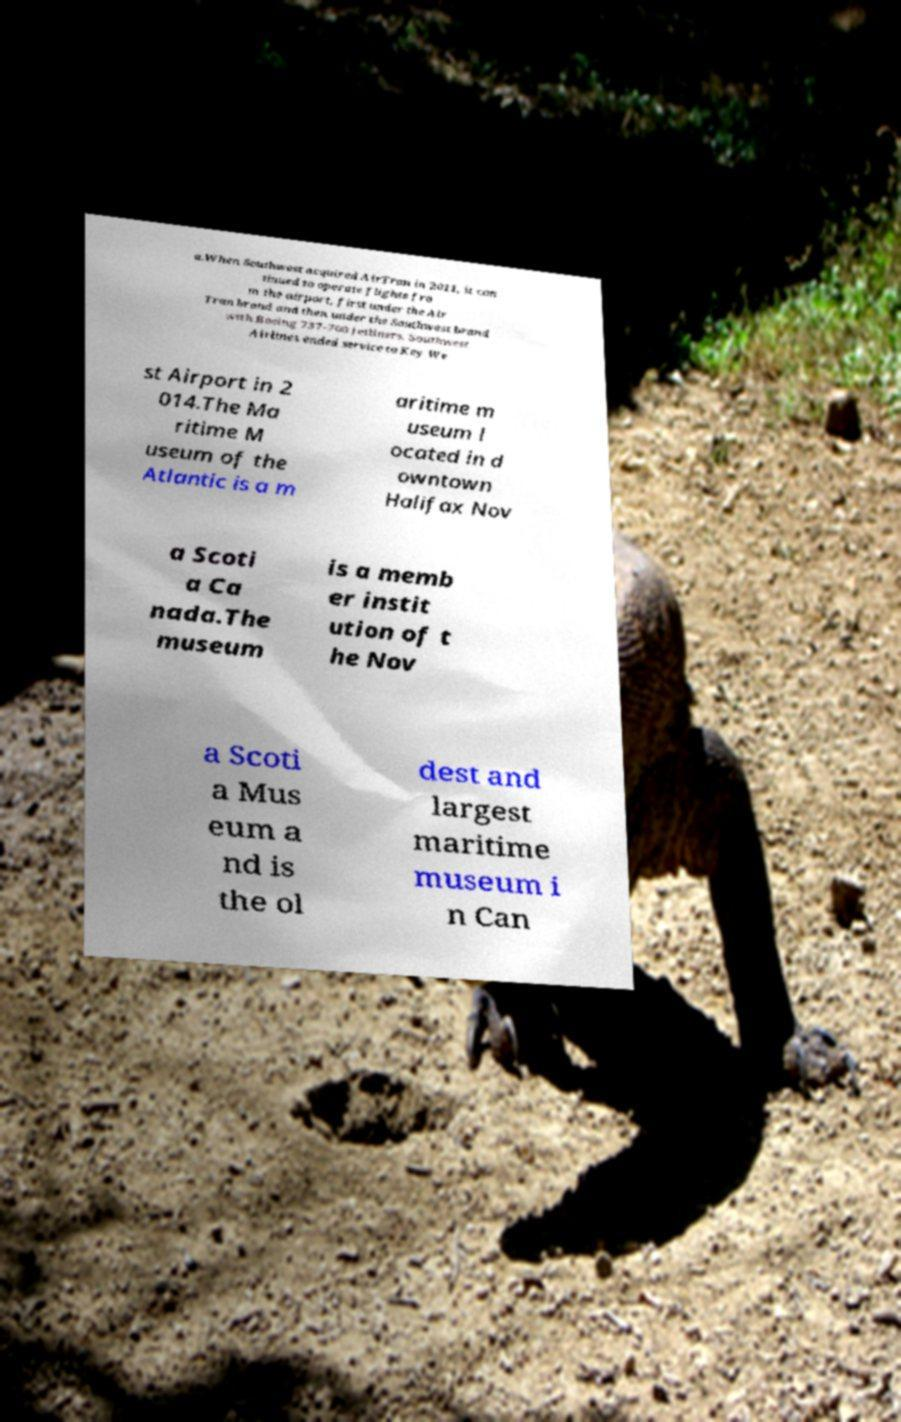I need the written content from this picture converted into text. Can you do that? a.When Southwest acquired AirTran in 2011, it con tinued to operate flights fro m the airport, first under the Air Tran brand and then under the Southwest brand with Boeing 737-700 jetliners. Southwest Airlines ended service to Key We st Airport in 2 014.The Ma ritime M useum of the Atlantic is a m aritime m useum l ocated in d owntown Halifax Nov a Scoti a Ca nada.The museum is a memb er instit ution of t he Nov a Scoti a Mus eum a nd is the ol dest and largest maritime museum i n Can 